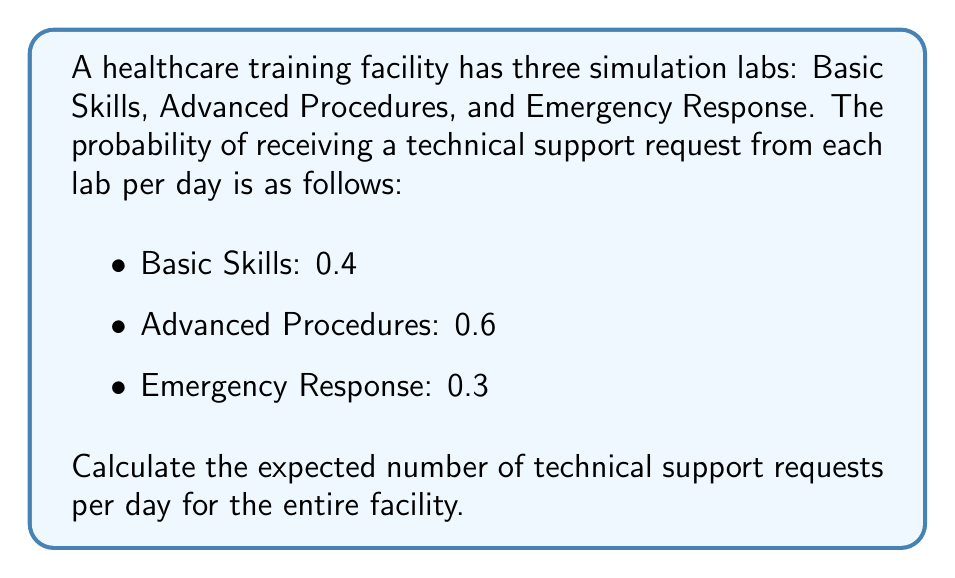Show me your answer to this math problem. To solve this problem, we'll use the concept of expected value. The expected value is the sum of each possible outcome multiplied by its probability.

Step 1: Define the random variable
Let X be the number of technical support requests per day.

Step 2: Identify possible outcomes
Each lab can either generate a request (1) or not (0). So, for each lab, we have:
P(request) = p
P(no request) = 1 - p

Step 3: Calculate the expected value for each lab
For a binary outcome (0 or 1), the expected value is equal to the probability of the event occurring.

Basic Skills: E(X_BS) = 0.4
Advanced Procedures: E(X_AP) = 0.6
Emergency Response: E(X_ER) = 0.3

Step 4: Calculate the total expected value
The total expected value is the sum of the expected values for each lab:

$$E(X_{total}) = E(X_{BS}) + E(X_{AP}) + E(X_{ER})$$
$$E(X_{total}) = 0.4 + 0.6 + 0.3 = 1.3$$

Therefore, the expected number of technical support requests per day for the entire facility is 1.3.
Answer: 1.3 requests per day 